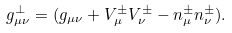Convert formula to latex. <formula><loc_0><loc_0><loc_500><loc_500>g ^ { \perp } _ { \mu \nu } = ( g _ { \mu \nu } + V ^ { \pm } _ { \mu } V ^ { \pm } _ { \nu } - n ^ { \pm } _ { \mu } n ^ { \pm } _ { \nu } ) .</formula> 